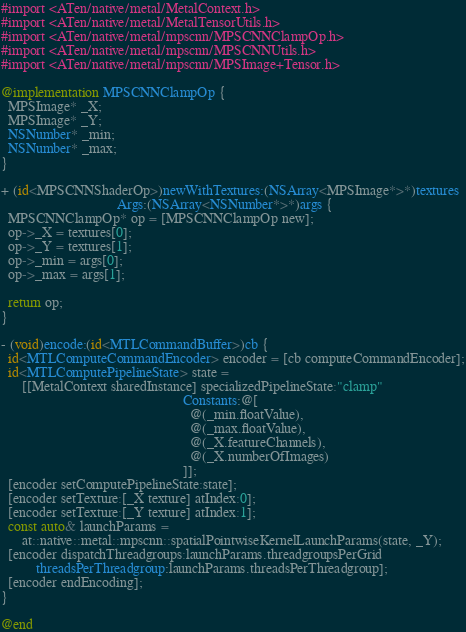<code> <loc_0><loc_0><loc_500><loc_500><_ObjectiveC_>#import <ATen/native/metal/MetalContext.h>
#import <ATen/native/metal/MetalTensorUtils.h>
#import <ATen/native/metal/mpscnn/MPSCNNClampOp.h>
#import <ATen/native/metal/mpscnn/MPSCNNUtils.h>
#import <ATen/native/metal/mpscnn/MPSImage+Tensor.h>

@implementation MPSCNNClampOp {
  MPSImage* _X;
  MPSImage* _Y;
  NSNumber* _min;
  NSNumber* _max;
}

+ (id<MPSCNNShaderOp>)newWithTextures:(NSArray<MPSImage*>*)textures
                                 Args:(NSArray<NSNumber*>*)args {
  MPSCNNClampOp* op = [MPSCNNClampOp new];
  op->_X = textures[0];
  op->_Y = textures[1];
  op->_min = args[0];
  op->_max = args[1];

  return op;
}

- (void)encode:(id<MTLCommandBuffer>)cb {
  id<MTLComputeCommandEncoder> encoder = [cb computeCommandEncoder];
  id<MTLComputePipelineState> state =
      [[MetalContext sharedInstance] specializedPipelineState:"clamp"
                                                    Constants:@[
                                                      @(_min.floatValue),
                                                      @(_max.floatValue),
                                                      @(_X.featureChannels),
                                                      @(_X.numberOfImages)
                                                    ]];
  [encoder setComputePipelineState:state];
  [encoder setTexture:[_X texture] atIndex:0];
  [encoder setTexture:[_Y texture] atIndex:1];
  const auto& launchParams =
      at::native::metal::mpscnn::spatialPointwiseKernelLaunchParams(state, _Y);
  [encoder dispatchThreadgroups:launchParams.threadgroupsPerGrid
          threadsPerThreadgroup:launchParams.threadsPerThreadgroup];
  [encoder endEncoding];
}

@end
</code> 